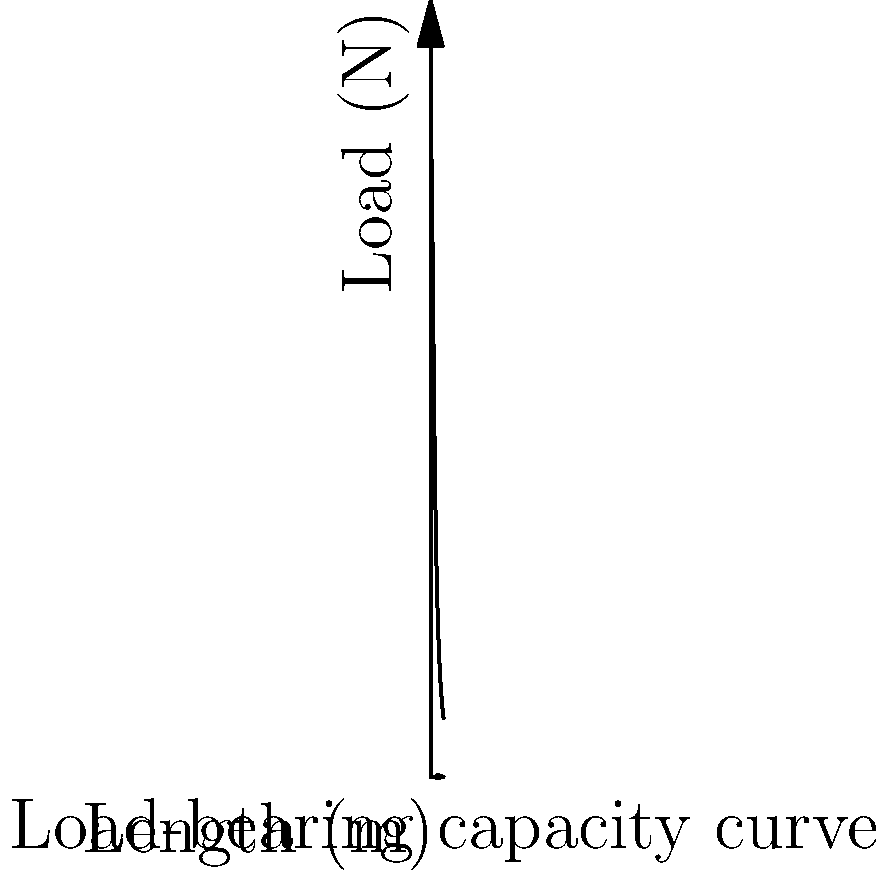You've discovered a uniquely shaped support beam for a new development project. The beam's load-bearing capacity (in Newtons) as a function of its length (in meters) is given by the equation:

$$ L(x) = \frac{5000}{x^2 + 10} $$

Where $L(x)$ is the load-bearing capacity and $x$ is the length of the beam. If you need to support a load of 250 N, what is the maximum length of beam you can use? Round your answer to the nearest tenth of a meter. To find the maximum length of the beam that can support 250 N, we need to solve the equation:

$$ 250 = \frac{5000}{x^2 + 10} $$

Step 1: Multiply both sides by $(x^2 + 10)$:
$$ 250(x^2 + 10) = 5000 $$

Step 2: Distribute the left side:
$$ 250x^2 + 2500 = 5000 $$

Step 3: Subtract 2500 from both sides:
$$ 250x^2 = 2500 $$

Step 4: Divide both sides by 250:
$$ x^2 = 10 $$

Step 5: Take the square root of both sides:
$$ x = \sqrt{10} \approx 3.162 $$

Step 6: Round to the nearest tenth:
$$ x \approx 3.2 \text{ meters} $$

Therefore, the maximum length of the beam that can support a 250 N load is approximately 3.2 meters.
Answer: 3.2 meters 